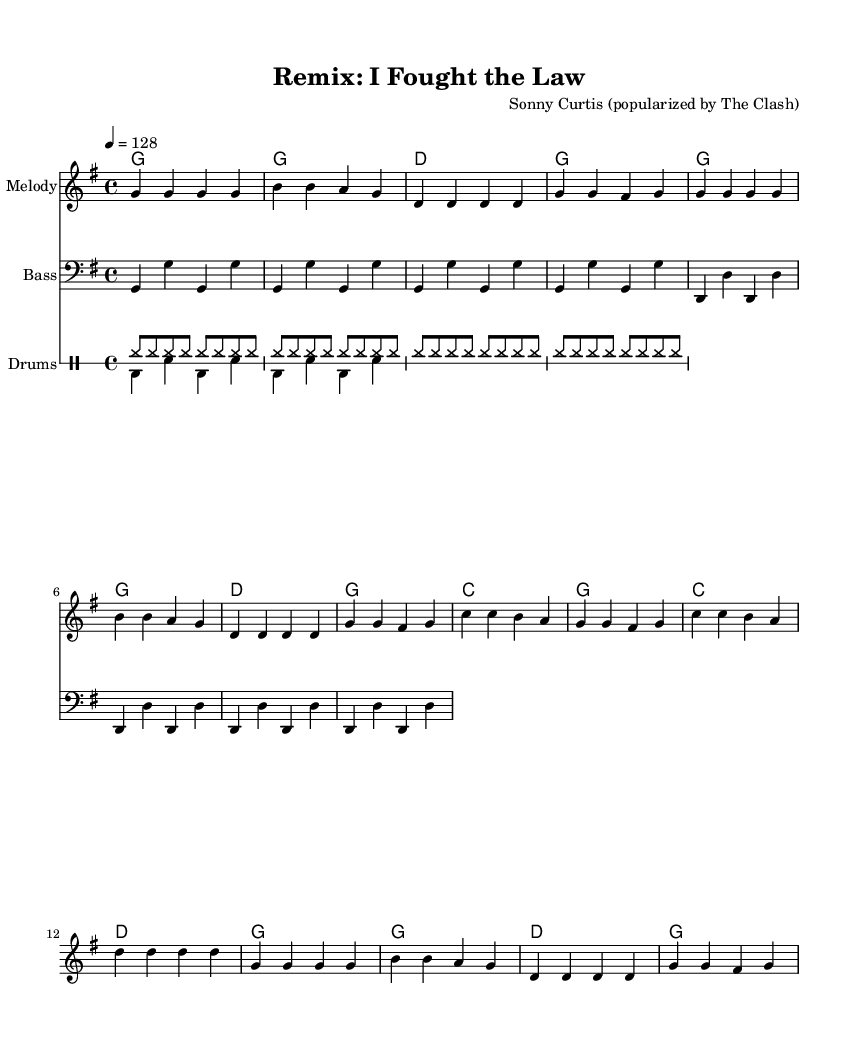What is the key signature of this music? The key signature is G major, which has one sharp (F#). This can be determined by looking at the key indicated in the global section of the code.
Answer: G major What is the time signature of this piece? The time signature is 4/4, as indicated in the global section of the sheet music. The notation 4/4 means there are four beats in each measure, and the quarter note gets one beat.
Answer: 4/4 What is the tempo marking provided in the music? The tempo marking is 128 beats per minute, determined from the tempo section of the code, which states "4 = 128". This indicates the speed of the music.
Answer: 128 How many measures are in each section of the piece? The verse consists of 8 measures, and the chorus also consists of 8 measures. This can be counted by looking at the melody and harmonies sections in the code, where each line of music corresponds to measures.
Answer: 8 What is the starting note of the melody in the verse? The starting note of the melody in the verse is G. The melody part begins with a series of G notes, as seen at the beginning of the melody section.
Answer: G What type of rhythm pattern is used for the drums in this remix? The rhythm pattern for the drums combines a hi-hat pattern played in eighth notes and a bass-drum/snare pattern. This can be seen in the drumPatternUp and drumPatternDown sections, which provide the specific rhythmic notation.
Answer: Upbeat What genre classification can be deduced for this music piece? The music can be classified as a dance remix, as indicated in the question prompt, focusing on upbeat rhythms and remixes of classic country songs. The lively tempo and structure further suggest it is intended for dance settings.
Answer: Dance remix 